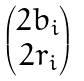<formula> <loc_0><loc_0><loc_500><loc_500>\begin{pmatrix} 2 b _ { i } \\ 2 r _ { i } \end{pmatrix}</formula> 